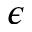<formula> <loc_0><loc_0><loc_500><loc_500>\epsilon</formula> 